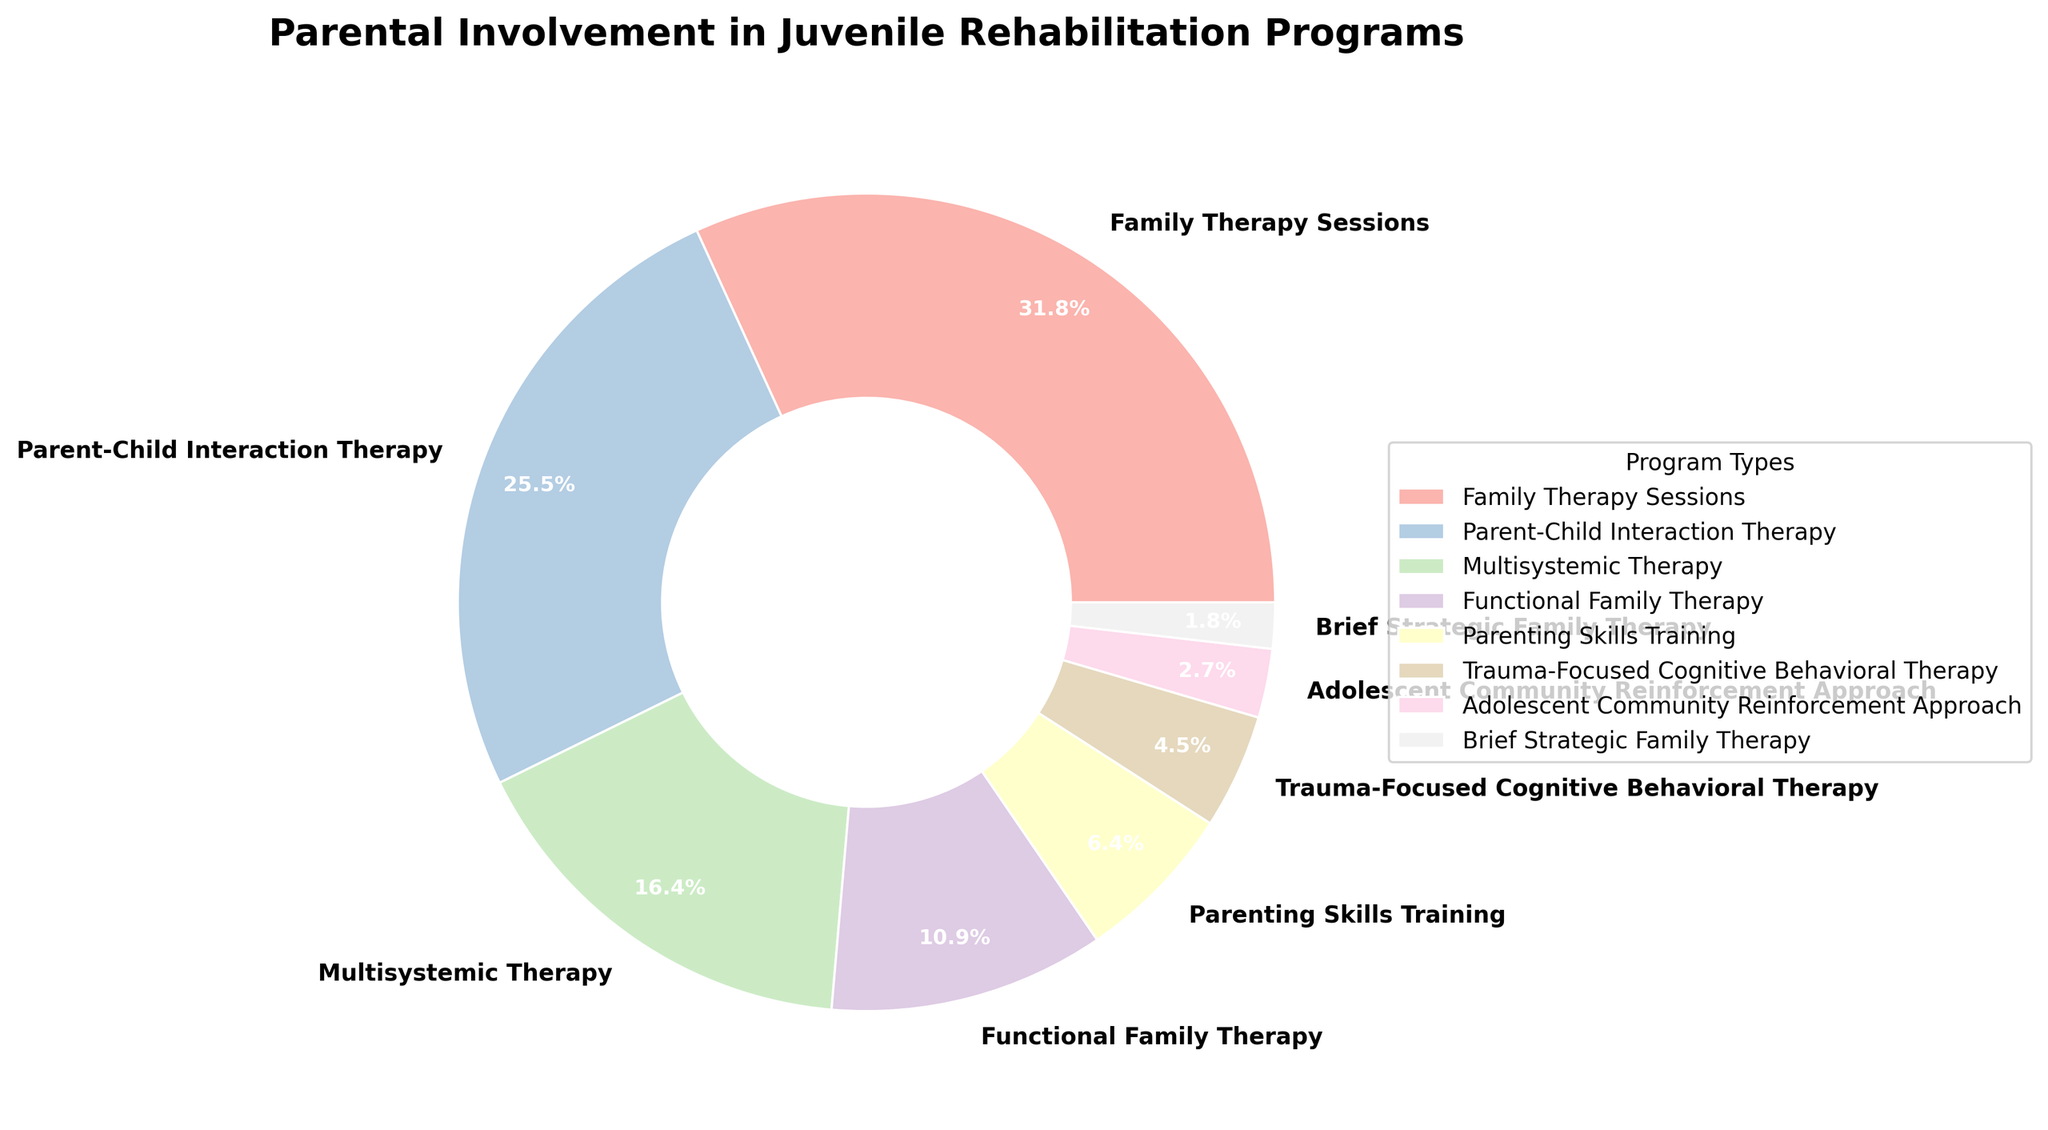What percentage of programs involve parental involvement greater than 20%? Determine the percentages of programs that have more than 20%. "Family Therapy Sessions" (35%) and "Parent-Child Interaction Therapy" (28%) qualify. Thus, there are two programs out of the total, making the percentage 2/8 * 100% = 25%.
Answer: 25% Which program has the highest level of parental involvement? Identify the program with the highest percentage in the pie chart. "Family Therapy Sessions" has the highest parental involvement at 35%.
Answer: Family Therapy Sessions What is the combined percentage of parental involvement in "Functional Family Therapy" and "Parenting Skills Training"? Sum the percentages of "Functional Family Therapy" (12%) and "Parenting Skills Training" (7%). 12% + 7% = 19%.
Answer: 19% How does the parental involvement in "Parent-Child Interaction Therapy" compare to "Multisystemic Therapy"? "Parent-Child Interaction Therapy" has 28% involvement, whereas "Multisystemic Therapy" has 18%. Comparing the two, 28% is greater than 18%.
Answer: Greater What is the smallest percentage of parental involvement recorded in juvenile rehabilitation programs? Identify the program with the lowest percentage in the pie chart. "Brief Strategic Family Therapy" has the smallest percentage at 2%.
Answer: 2% Which two programs together make up over half of the total parental involvement percentage? Adding the two largest percentages: "Family Therapy Sessions" (35%) and "Parent-Child Interaction Therapy" (28%). 35% + 28% = 63%, which is over half.
Answer: Family Therapy Sessions and Parent-Child Interaction Therapy What is the average percentage of parental involvement across all programs? Sum the percentages and divide by the number of programs: (35 + 28 + 18 + 12 + 7 + 5 + 3 + 2) = 110%. 110 / 8 = 13.75%.
Answer: 13.75% How many programs have a parental involvement percentage that is less than the average percentage? Calculate the average as 13.75% from the previous answer. Count programs with less than 13.75% involvement: "Parenting Skills Training" (7%), "Trauma-Focused Cognitive Behavioral Therapy" (5%), "Adolescent Community Reinforcement Approach" (3%), and "Brief Strategic Family Therapy" (2%). There are four programs.
Answer: 4 